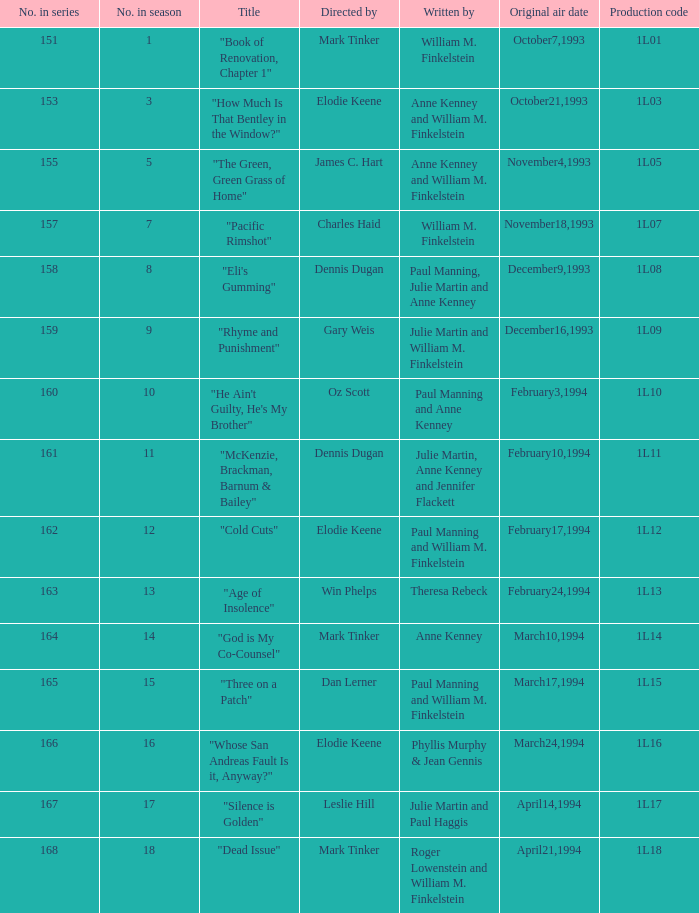Can you provide the name of the director in charge of the production coded 1l10? Oz Scott. 